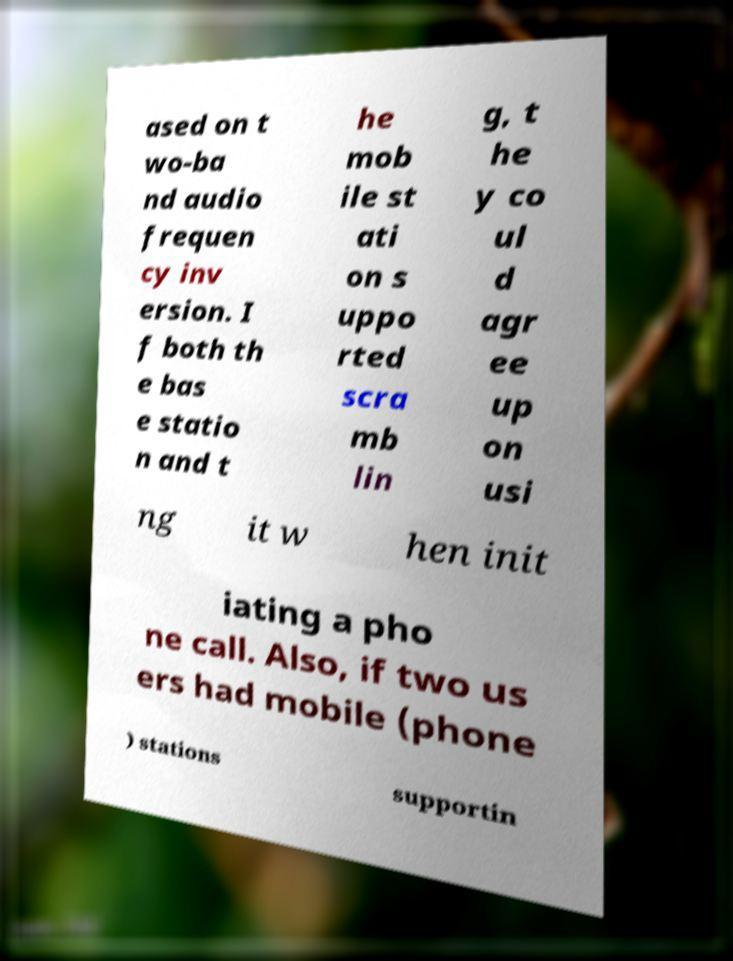Could you assist in decoding the text presented in this image and type it out clearly? ased on t wo-ba nd audio frequen cy inv ersion. I f both th e bas e statio n and t he mob ile st ati on s uppo rted scra mb lin g, t he y co ul d agr ee up on usi ng it w hen init iating a pho ne call. Also, if two us ers had mobile (phone ) stations supportin 